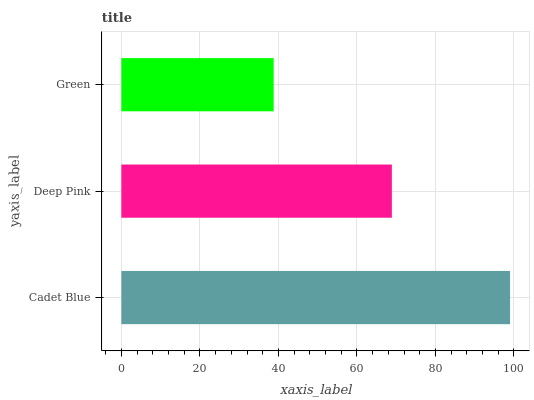Is Green the minimum?
Answer yes or no. Yes. Is Cadet Blue the maximum?
Answer yes or no. Yes. Is Deep Pink the minimum?
Answer yes or no. No. Is Deep Pink the maximum?
Answer yes or no. No. Is Cadet Blue greater than Deep Pink?
Answer yes or no. Yes. Is Deep Pink less than Cadet Blue?
Answer yes or no. Yes. Is Deep Pink greater than Cadet Blue?
Answer yes or no. No. Is Cadet Blue less than Deep Pink?
Answer yes or no. No. Is Deep Pink the high median?
Answer yes or no. Yes. Is Deep Pink the low median?
Answer yes or no. Yes. Is Cadet Blue the high median?
Answer yes or no. No. Is Green the low median?
Answer yes or no. No. 